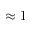<formula> <loc_0><loc_0><loc_500><loc_500>\approx 1</formula> 